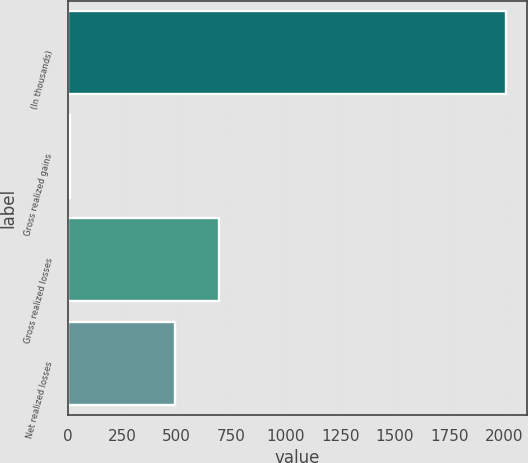Convert chart to OTSL. <chart><loc_0><loc_0><loc_500><loc_500><bar_chart><fcel>(In thousands)<fcel>Gross realized gains<fcel>Gross realized losses<fcel>Net realized losses<nl><fcel>2006<fcel>12<fcel>693.4<fcel>494<nl></chart> 